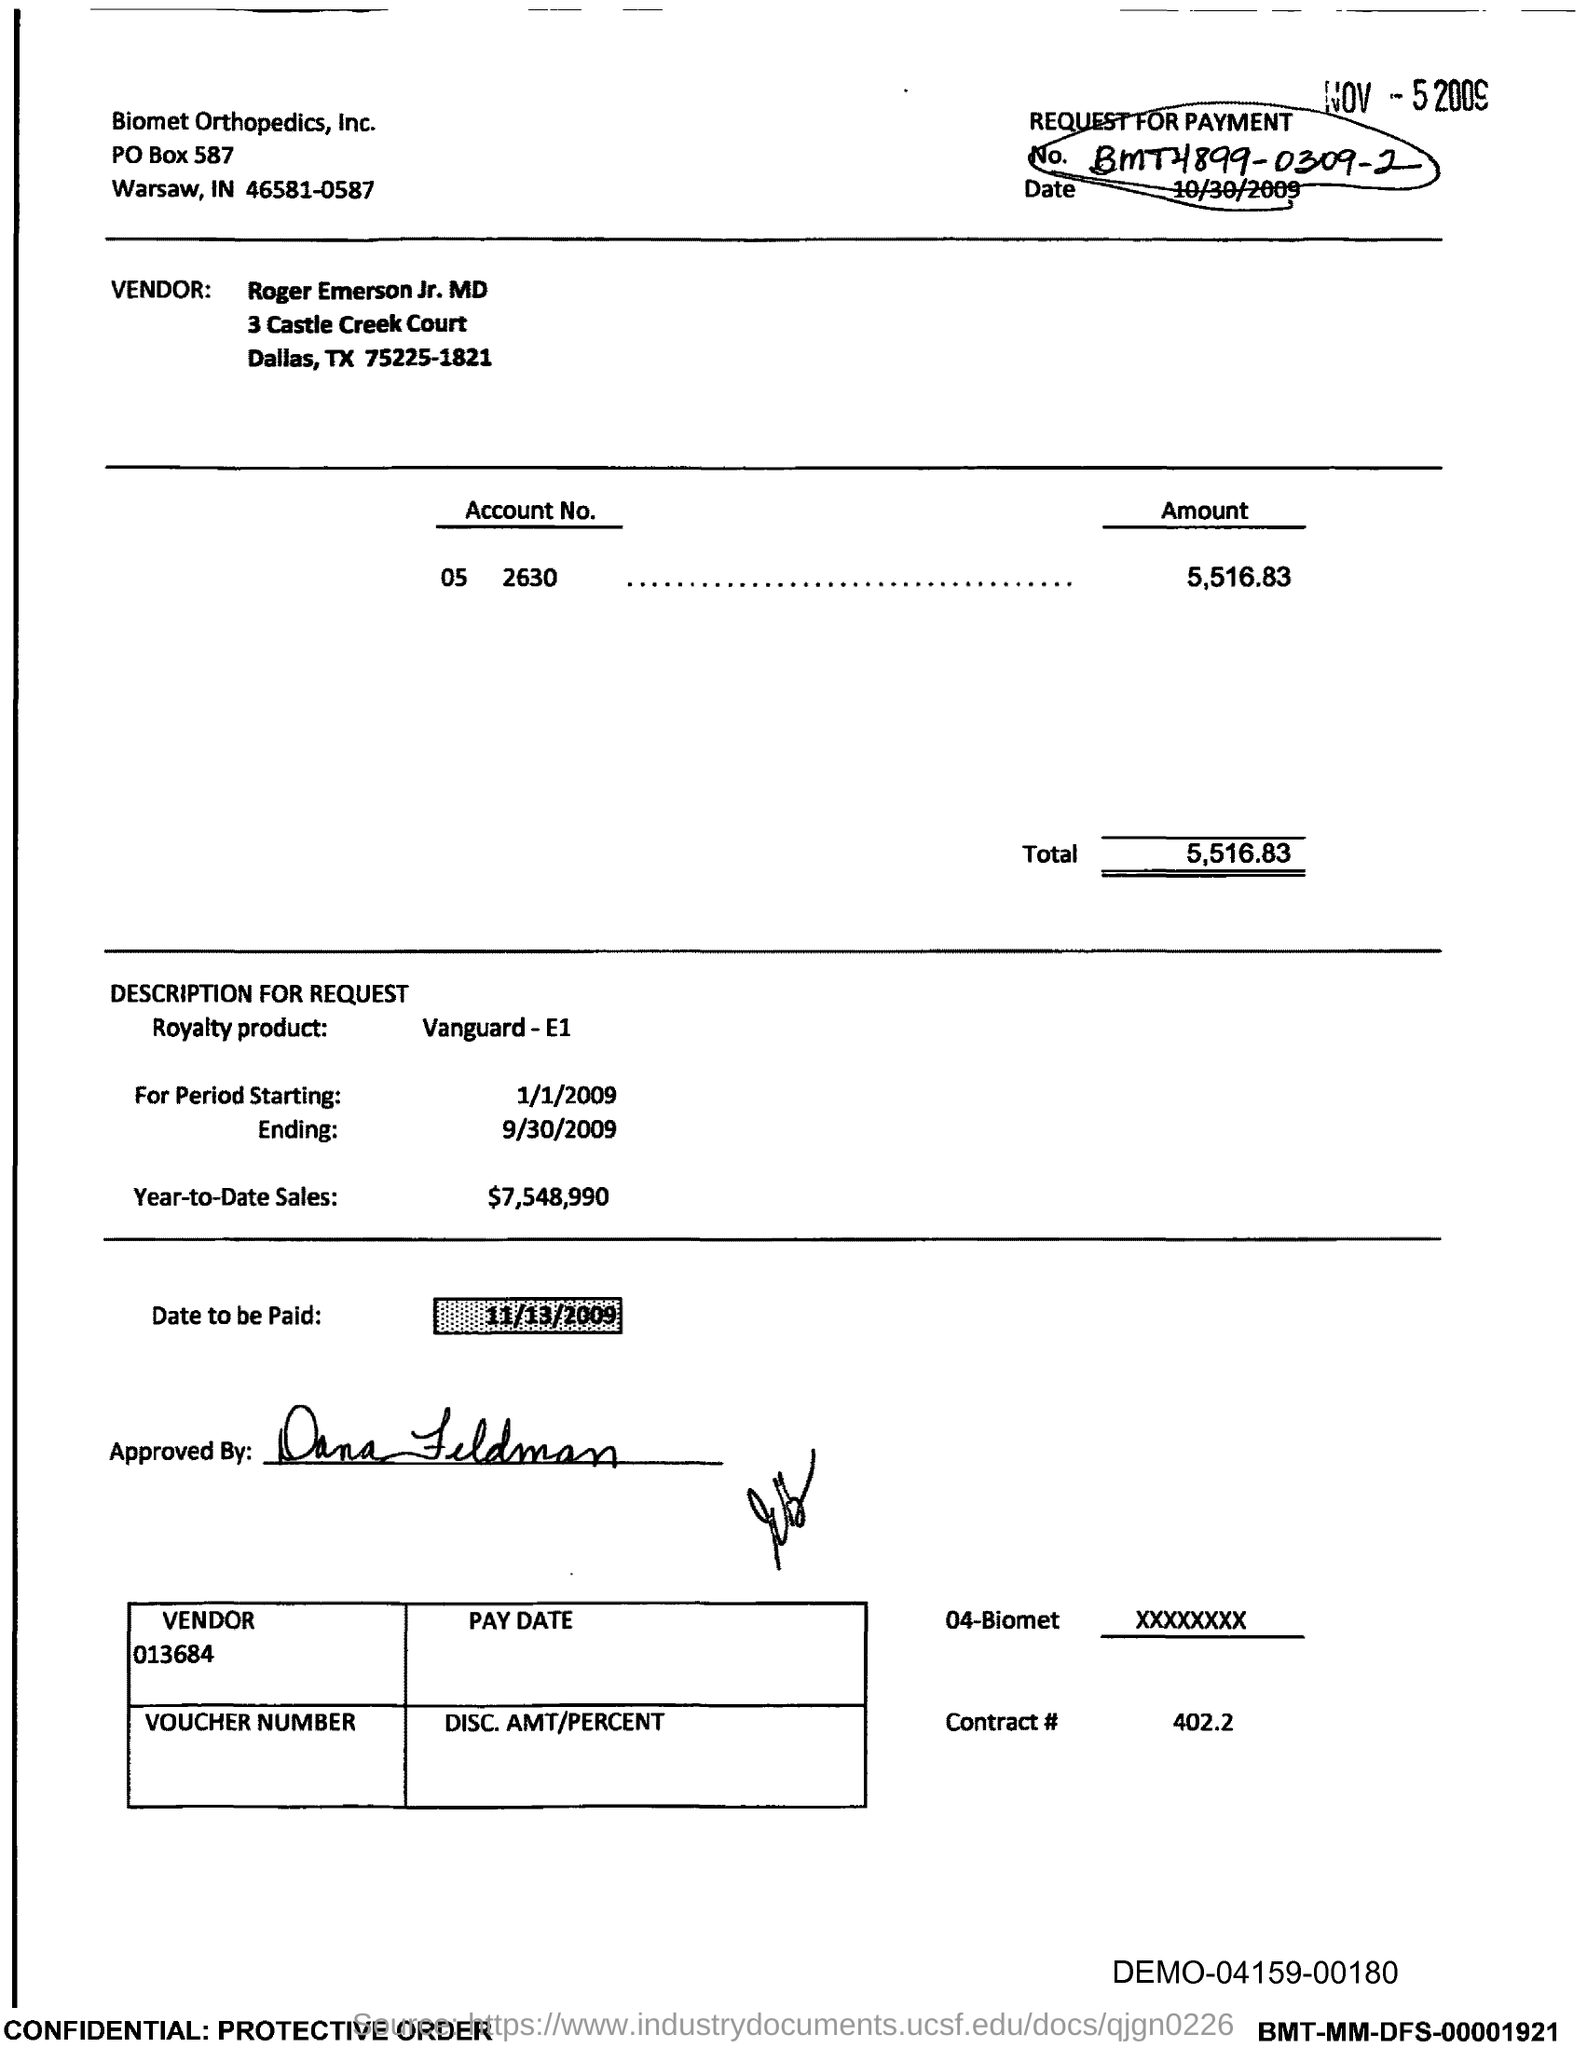Identify some key points in this picture. The ending period mentioned is September 30, 2009. The total amount specified is 5,516.83. What is the date to be paid? The date to be paid is 11/13/2009. The year-to-date sales as of today are $7,548,990. The starting period is from 1/1/2009. 